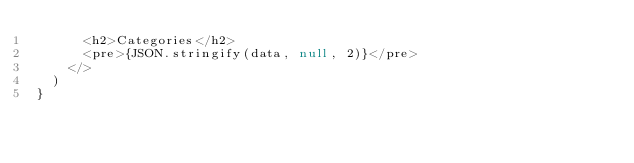<code> <loc_0><loc_0><loc_500><loc_500><_JavaScript_>      <h2>Categories</h2>
      <pre>{JSON.stringify(data, null, 2)}</pre>
    </>
  )
}
</code> 